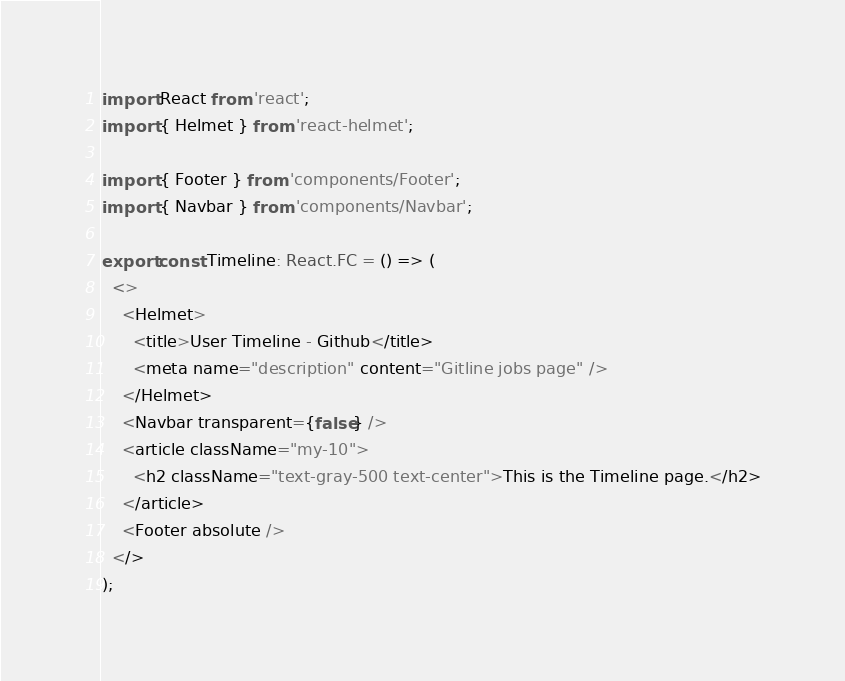<code> <loc_0><loc_0><loc_500><loc_500><_TypeScript_>import React from 'react';
import { Helmet } from 'react-helmet';

import { Footer } from 'components/Footer';
import { Navbar } from 'components/Navbar';

export const Timeline: React.FC = () => (
  <>
    <Helmet>
      <title>User Timeline - Github</title>
      <meta name="description" content="Gitline jobs page" />
    </Helmet>
    <Navbar transparent={false} />
    <article className="my-10">
      <h2 className="text-gray-500 text-center">This is the Timeline page.</h2>
    </article>
    <Footer absolute />
  </>
);
</code> 